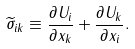Convert formula to latex. <formula><loc_0><loc_0><loc_500><loc_500>\widetilde { \sigma } _ { i k } \equiv \frac { \partial U _ { i } } { \partial x _ { k } } + \frac { \partial U _ { k } } { \partial x _ { i } } .</formula> 